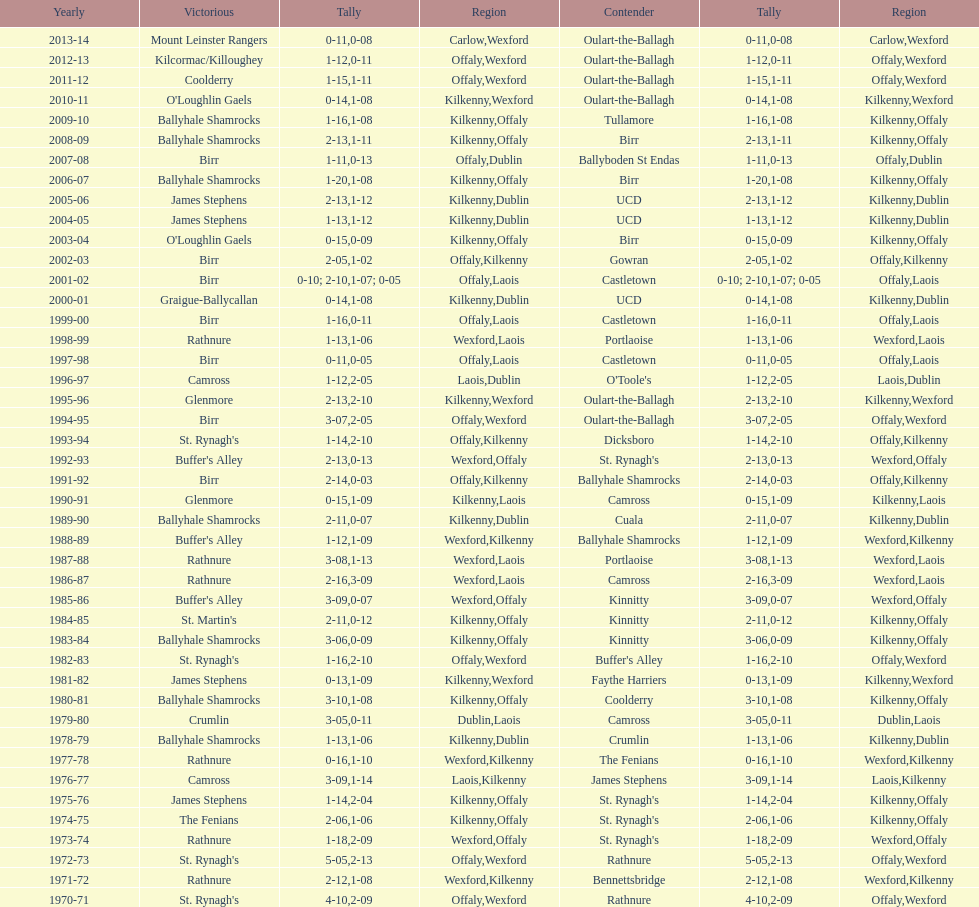Which team won the leinster senior club hurling championships previous to the last time birr won? Ballyhale Shamrocks. 